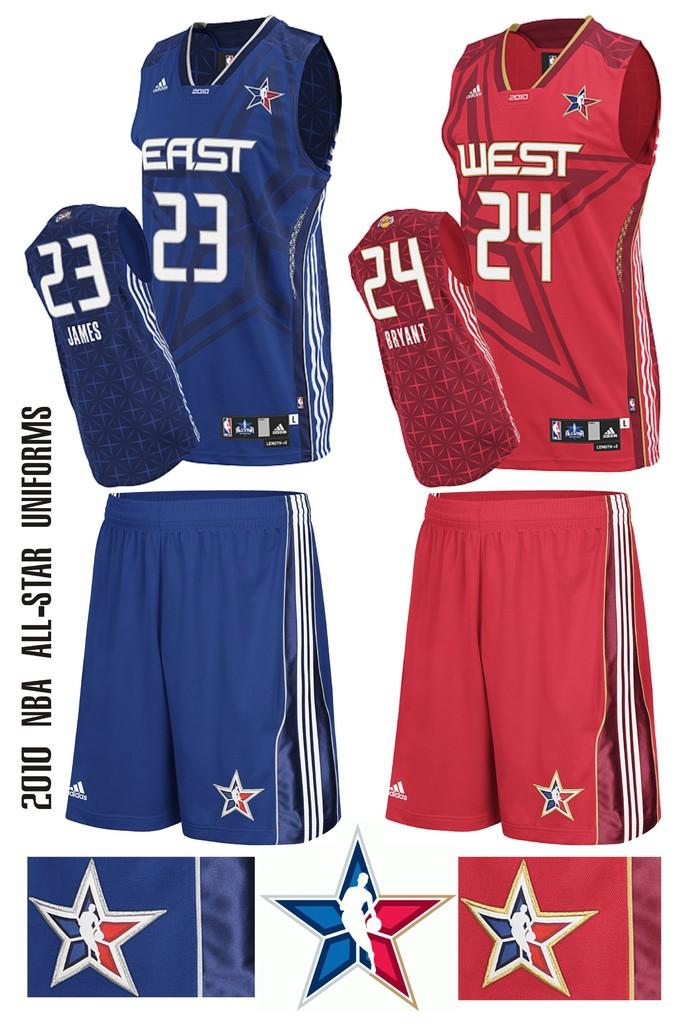<image>
Share a concise interpretation of the image provided. No north or south here just east and west. 